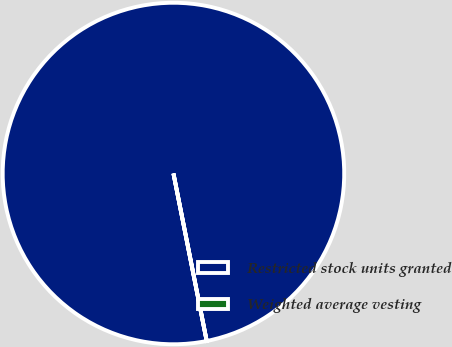Convert chart to OTSL. <chart><loc_0><loc_0><loc_500><loc_500><pie_chart><fcel>Restricted stock units granted<fcel>Weighted average vesting<nl><fcel>100.0%<fcel>0.0%<nl></chart> 